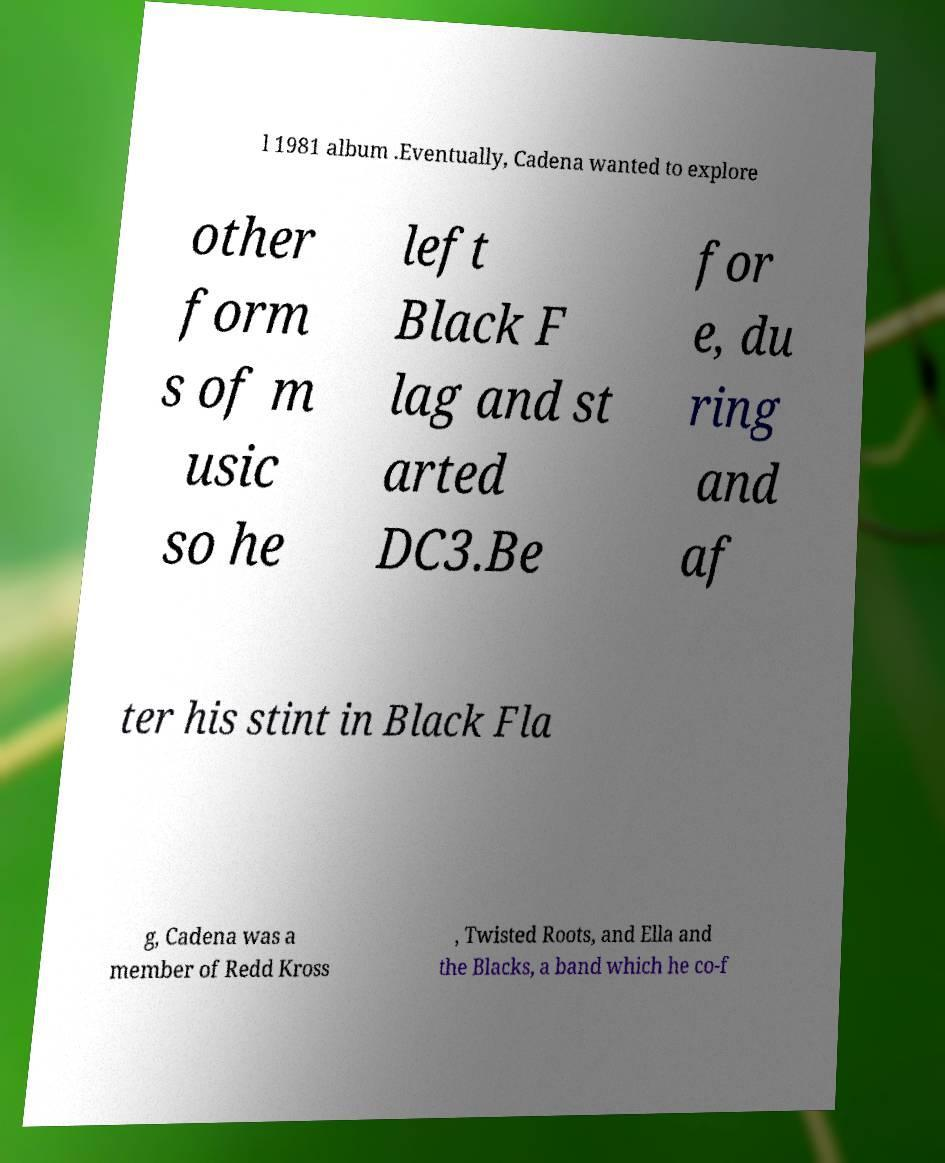Please read and relay the text visible in this image. What does it say? l 1981 album .Eventually, Cadena wanted to explore other form s of m usic so he left Black F lag and st arted DC3.Be for e, du ring and af ter his stint in Black Fla g, Cadena was a member of Redd Kross , Twisted Roots, and Ella and the Blacks, a band which he co-f 